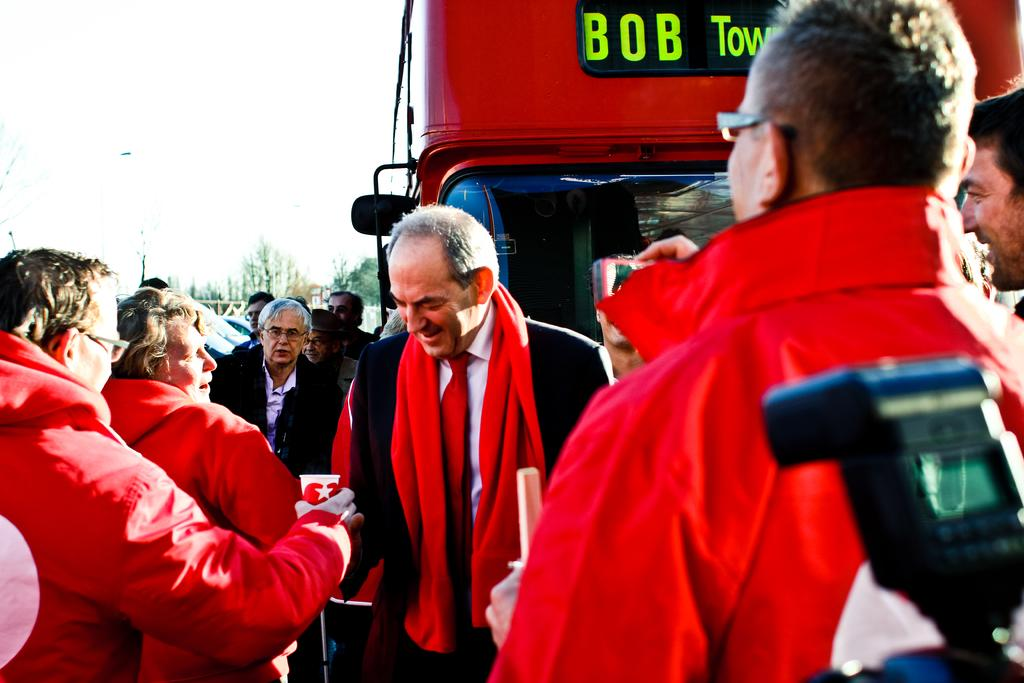What is located in front of the image? There are people in front of the image. What type of vehicle is present in the image? There is a vehicle with letters on it. What can be seen in the background of the image? There are trees in the background of the image. What is visible at the top of the image? The sky is visible at the top of the image. Can you see any guns in the image? There is no gun present in the image. What type of nose is visible on the people in the image? The image does not show the noses of the people, so it cannot be determined from the image. 